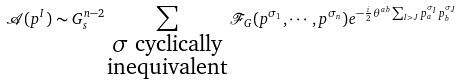<formula> <loc_0><loc_0><loc_500><loc_500>\mathcal { A } ( p ^ { I } ) \sim G _ { s } ^ { n - 2 } \sum _ { \substack { \sigma \text { cyclically} \\ \text {inequivalent} } } \mathcal { F } _ { G } ( p ^ { \sigma _ { 1 } } , \cdots , p ^ { \sigma _ { n } } ) e ^ { - \frac { i } { 2 } \theta ^ { a b } \sum _ { I > J } p _ { a } ^ { \sigma _ { I } } p _ { b } ^ { \sigma _ { J } } }</formula> 